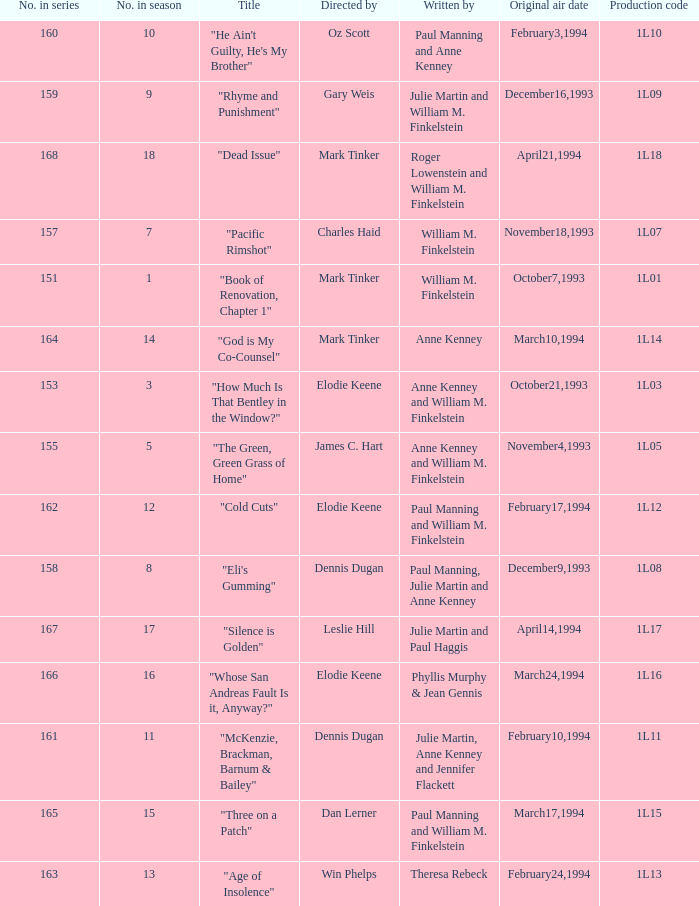Name the most number in season for leslie hill 17.0. 